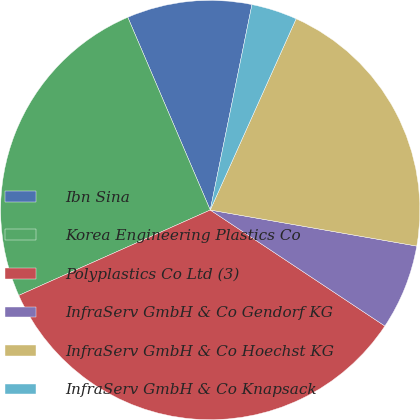Convert chart to OTSL. <chart><loc_0><loc_0><loc_500><loc_500><pie_chart><fcel>Ibn Sina<fcel>Korea Engineering Plastics Co<fcel>Polyplastics Co Ltd (3)<fcel>InfraServ GmbH & Co Gendorf KG<fcel>InfraServ GmbH & Co Hoechst KG<fcel>InfraServ GmbH & Co Knapsack<nl><fcel>9.62%<fcel>25.24%<fcel>33.99%<fcel>6.58%<fcel>21.03%<fcel>3.53%<nl></chart> 